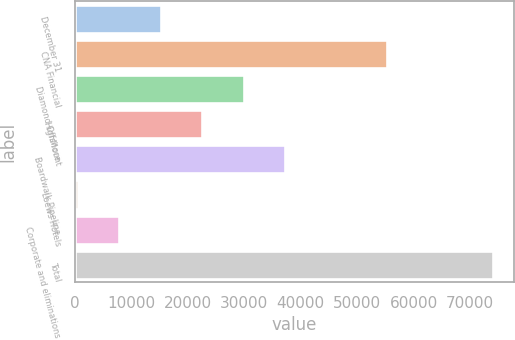<chart> <loc_0><loc_0><loc_500><loc_500><bar_chart><fcel>December 31<fcel>CNA Financial<fcel>Diamond Offshore<fcel>HighMount<fcel>Boardwalk Pipeline<fcel>Loews Hotels<fcel>Corporate and eliminations<fcel>Total<nl><fcel>15193.2<fcel>55241<fcel>29912.4<fcel>22552.8<fcel>37272<fcel>474<fcel>7833.6<fcel>74070<nl></chart> 